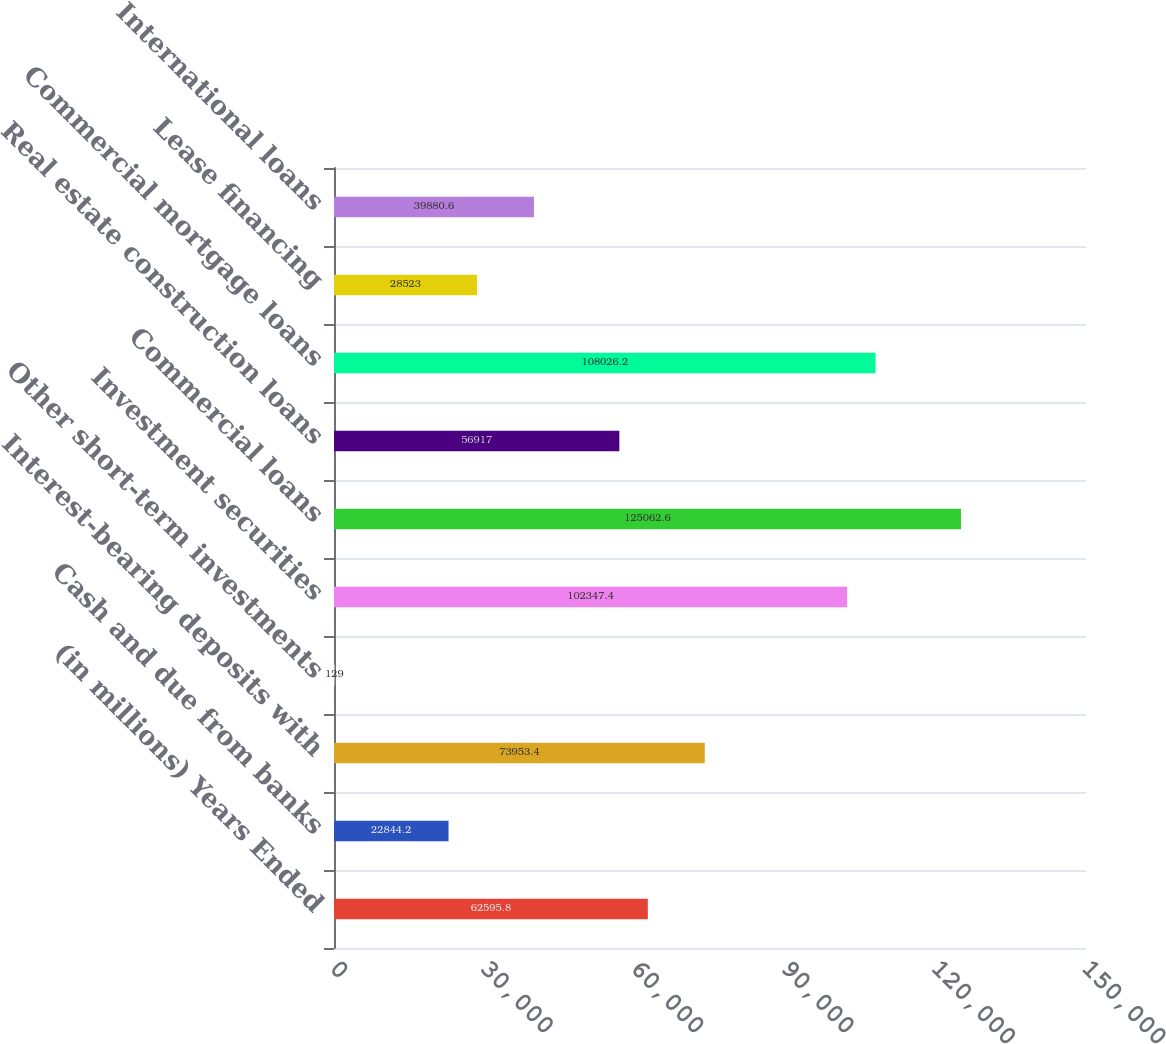Convert chart to OTSL. <chart><loc_0><loc_0><loc_500><loc_500><bar_chart><fcel>(in millions) Years Ended<fcel>Cash and due from banks<fcel>Interest-bearing deposits with<fcel>Other short-term investments<fcel>Investment securities<fcel>Commercial loans<fcel>Real estate construction loans<fcel>Commercial mortgage loans<fcel>Lease financing<fcel>International loans<nl><fcel>62595.8<fcel>22844.2<fcel>73953.4<fcel>129<fcel>102347<fcel>125063<fcel>56917<fcel>108026<fcel>28523<fcel>39880.6<nl></chart> 